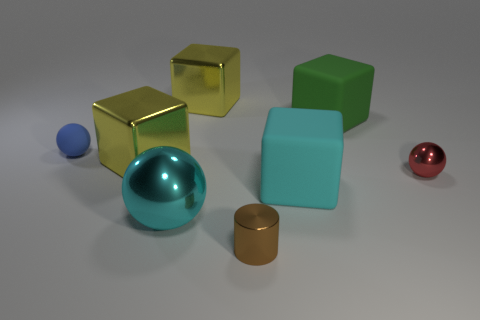Subtract all shiny balls. How many balls are left? 1 Subtract all red spheres. How many spheres are left? 2 Add 1 blocks. How many objects exist? 9 Subtract 2 blocks. How many blocks are left? 2 Subtract all brown cylinders. How many red balls are left? 1 Add 7 red spheres. How many red spheres exist? 8 Subtract 0 cyan cylinders. How many objects are left? 8 Subtract all cylinders. How many objects are left? 7 Subtract all yellow cubes. Subtract all gray balls. How many cubes are left? 2 Subtract all metallic cylinders. Subtract all tiny rubber spheres. How many objects are left? 6 